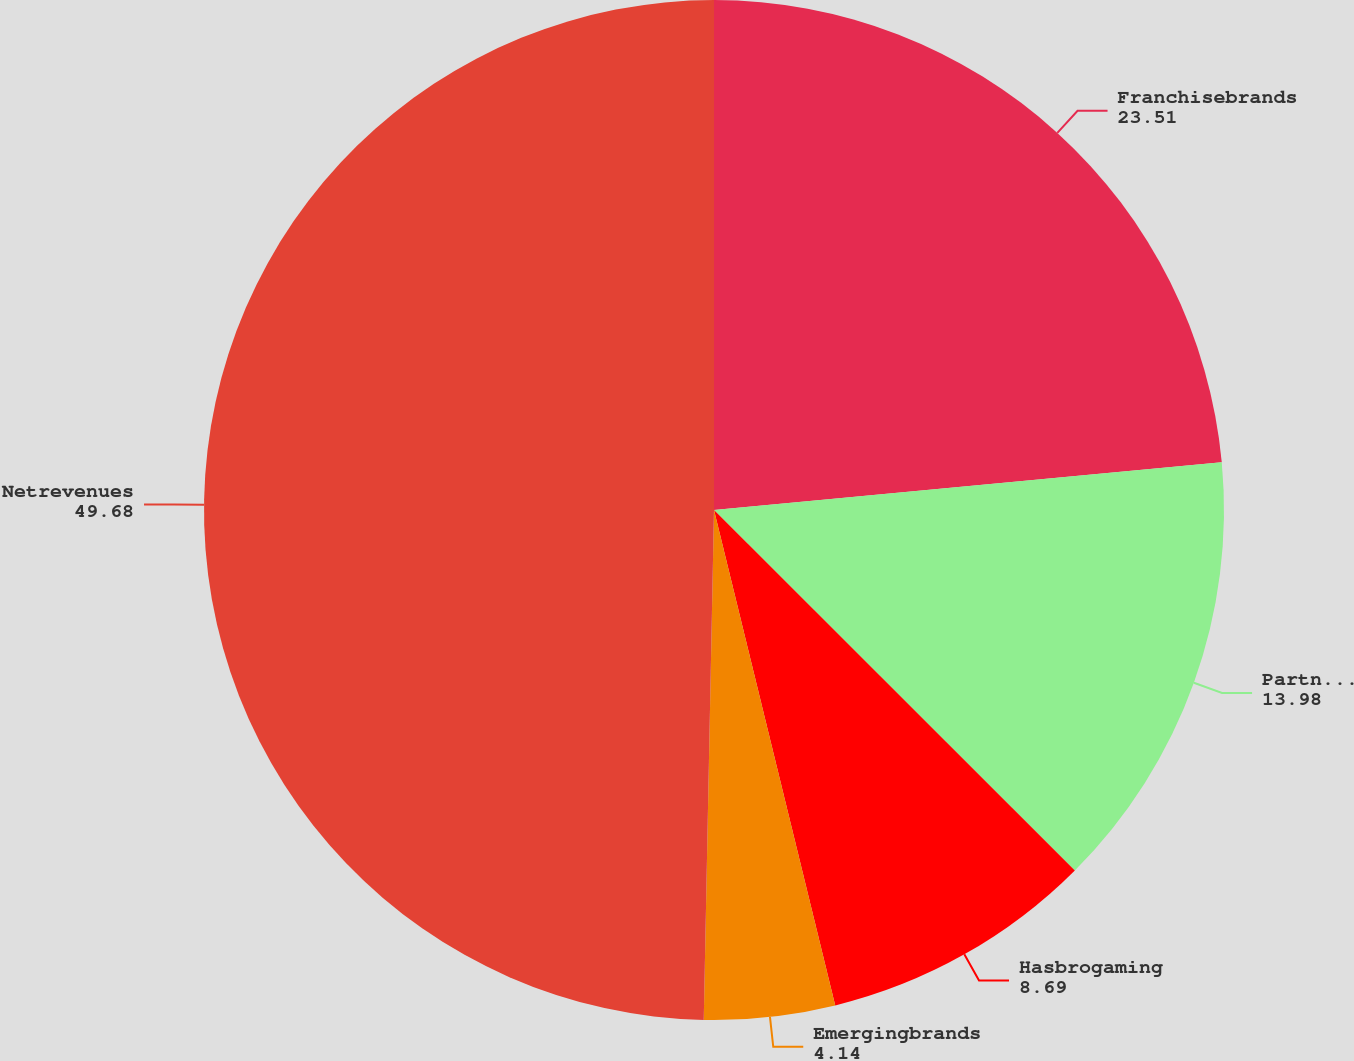Convert chart. <chart><loc_0><loc_0><loc_500><loc_500><pie_chart><fcel>Franchisebrands<fcel>Partnerbrands<fcel>Hasbrogaming<fcel>Emergingbrands<fcel>Netrevenues<nl><fcel>23.51%<fcel>13.98%<fcel>8.69%<fcel>4.14%<fcel>49.68%<nl></chart> 